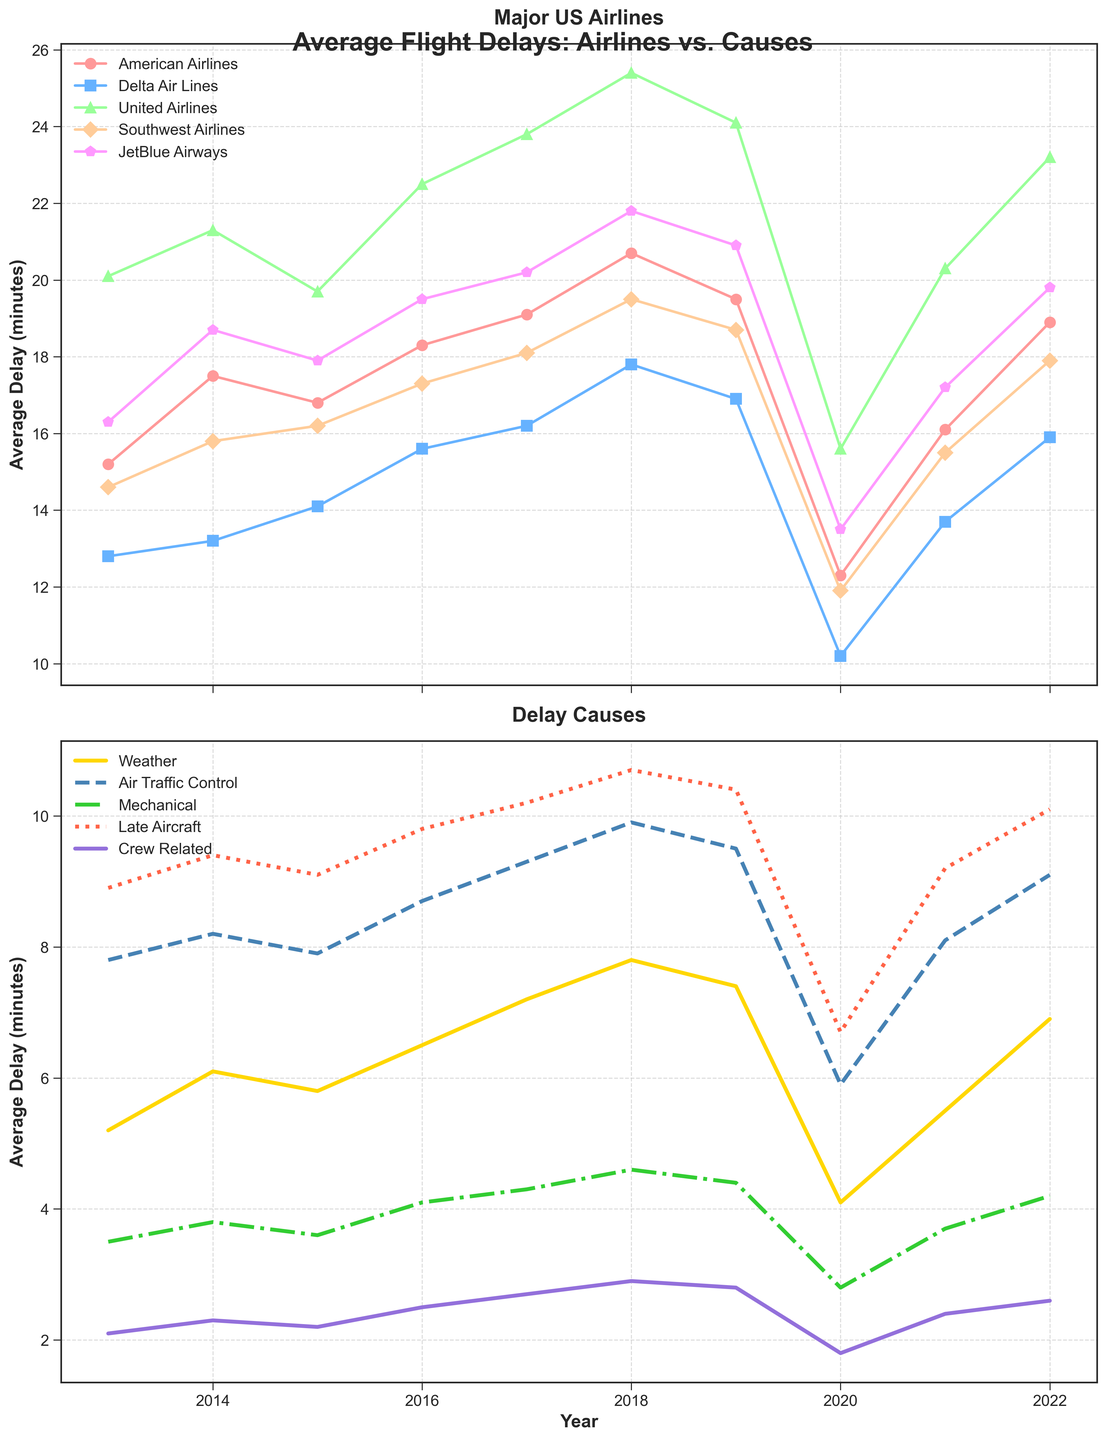What's the trend of average flight delays for Delta Air Lines from 2013 to 2022? Delta Air Lines shows an increasing trend from 2013 to 2018, peaking at around 17.8 minutes. There is a dip in 2020 to 10.2 minutes and then an increase again to 15.9 minutes in 2022.
Answer: Increasing, peaking at 17.8 minutes, dip in 2020, then rising again Which airline had the highest average delay in 2018? By looking at the top subplot for 2018, United Airlines had the highest average delay, as its line reaches above 25 minutes.
Answer: United Airlines Which cause contributed the least to flight delays on average in 2020? Refer to the bottom subplot for 2020, the cause 'Crew Related' had the lowest average delay of about 1.8 minutes.
Answer: Crew Related In which year did American Airlines experience the highest average delay? Check the line representing American Airlines in the top subplot; the highest point is in 2018, with an average delay of 20.7 minutes.
Answer: 2018 By how many minutes did the average delay for Crew Related causes increase from 2013 to 2022? Subtract the average delay of Crew Related in 2013 (2.1 minutes) from its value in 2022 (2.6 minutes): 2.6 - 2.1 = 0.5 minutes.
Answer: 0.5 minutes Which had a greater impact on delays in 2017, Mechanical issues or Weather? Compare the heights of the lines for Mechanical and Weather in 2017 in the bottom subplot; Weather (around 7.2 minutes) is greater than Mechanical (around 4.3 minutes).
Answer: Weather How did the delays due to Late Aircraft change from 2019 to 2020? Find the line for Late Aircraft and compare 2019 and 2020 values; it decreased from about 10.4 minutes to about 6.7 minutes.
Answer: Decreased What is the difference in average delays between Southwest Airlines and JetBlue Airways in 2016? Look at the values for Southwest Airlines (17.3 minutes) and JetBlue Airways (19.5 minutes) for 2016 and subtract them: 19.5 - 17.3 = 2.2 minutes.
Answer: 2.2 minutes Which year showed the highest average delay caused by Air Traffic Control? Locate the highest point on the Air Traffic Control line in the bottom subplot; it is in 2018, around 9.9 minutes.
Answer: 2018 Comparing 2020 and 2021, did the average delays due to Weather increase or decrease? Compare the Weather line in the bottom subplot for 2020 (4.1 minutes) and 2021 (5.5 minutes); it increased.
Answer: Increased 